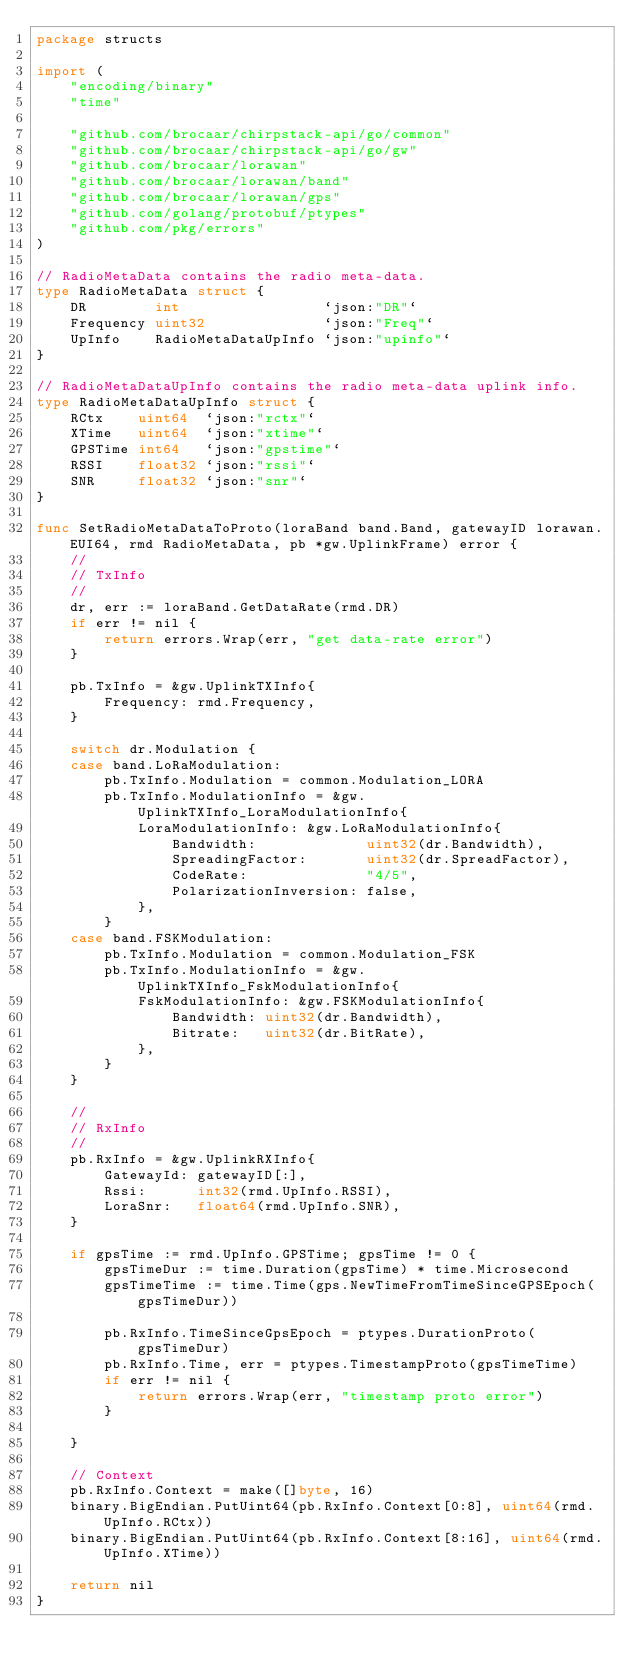<code> <loc_0><loc_0><loc_500><loc_500><_Go_>package structs

import (
	"encoding/binary"
	"time"

	"github.com/brocaar/chirpstack-api/go/common"
	"github.com/brocaar/chirpstack-api/go/gw"
	"github.com/brocaar/lorawan"
	"github.com/brocaar/lorawan/band"
	"github.com/brocaar/lorawan/gps"
	"github.com/golang/protobuf/ptypes"
	"github.com/pkg/errors"
)

// RadioMetaData contains the radio meta-data.
type RadioMetaData struct {
	DR        int                 `json:"DR"`
	Frequency uint32              `json:"Freq"`
	UpInfo    RadioMetaDataUpInfo `json:"upinfo"`
}

// RadioMetaDataUpInfo contains the radio meta-data uplink info.
type RadioMetaDataUpInfo struct {
	RCtx    uint64  `json:"rctx"`
	XTime   uint64  `json:"xtime"`
	GPSTime int64   `json:"gpstime"`
	RSSI    float32 `json:"rssi"`
	SNR     float32 `json:"snr"`
}

func SetRadioMetaDataToProto(loraBand band.Band, gatewayID lorawan.EUI64, rmd RadioMetaData, pb *gw.UplinkFrame) error {
	//
	// TxInfo
	//
	dr, err := loraBand.GetDataRate(rmd.DR)
	if err != nil {
		return errors.Wrap(err, "get data-rate error")
	}

	pb.TxInfo = &gw.UplinkTXInfo{
		Frequency: rmd.Frequency,
	}

	switch dr.Modulation {
	case band.LoRaModulation:
		pb.TxInfo.Modulation = common.Modulation_LORA
		pb.TxInfo.ModulationInfo = &gw.UplinkTXInfo_LoraModulationInfo{
			LoraModulationInfo: &gw.LoRaModulationInfo{
				Bandwidth:             uint32(dr.Bandwidth),
				SpreadingFactor:       uint32(dr.SpreadFactor),
				CodeRate:              "4/5",
				PolarizationInversion: false,
			},
		}
	case band.FSKModulation:
		pb.TxInfo.Modulation = common.Modulation_FSK
		pb.TxInfo.ModulationInfo = &gw.UplinkTXInfo_FskModulationInfo{
			FskModulationInfo: &gw.FSKModulationInfo{
				Bandwidth: uint32(dr.Bandwidth),
				Bitrate:   uint32(dr.BitRate),
			},
		}
	}

	//
	// RxInfo
	//
	pb.RxInfo = &gw.UplinkRXInfo{
		GatewayId: gatewayID[:],
		Rssi:      int32(rmd.UpInfo.RSSI),
		LoraSnr:   float64(rmd.UpInfo.SNR),
	}

	if gpsTime := rmd.UpInfo.GPSTime; gpsTime != 0 {
		gpsTimeDur := time.Duration(gpsTime) * time.Microsecond
		gpsTimeTime := time.Time(gps.NewTimeFromTimeSinceGPSEpoch(gpsTimeDur))

		pb.RxInfo.TimeSinceGpsEpoch = ptypes.DurationProto(gpsTimeDur)
		pb.RxInfo.Time, err = ptypes.TimestampProto(gpsTimeTime)
		if err != nil {
			return errors.Wrap(err, "timestamp proto error")
		}

	}

	// Context
	pb.RxInfo.Context = make([]byte, 16)
	binary.BigEndian.PutUint64(pb.RxInfo.Context[0:8], uint64(rmd.UpInfo.RCtx))
	binary.BigEndian.PutUint64(pb.RxInfo.Context[8:16], uint64(rmd.UpInfo.XTime))

	return nil
}
</code> 